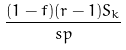<formula> <loc_0><loc_0><loc_500><loc_500>\frac { ( 1 - f ) ( r - 1 ) S _ { k } } { s p }</formula> 